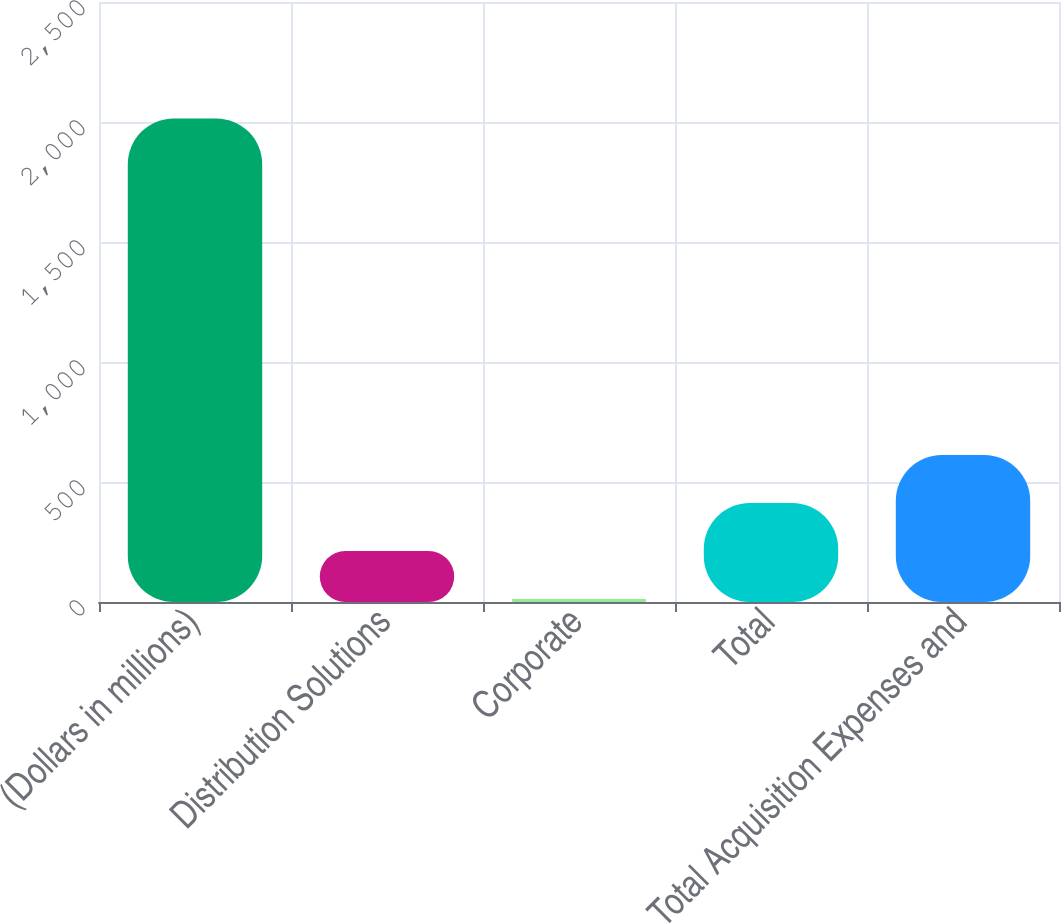<chart> <loc_0><loc_0><loc_500><loc_500><bar_chart><fcel>(Dollars in millions)<fcel>Distribution Solutions<fcel>Corporate<fcel>Total<fcel>Total Acquisition Expenses and<nl><fcel>2015<fcel>212.3<fcel>12<fcel>412.6<fcel>612.9<nl></chart> 